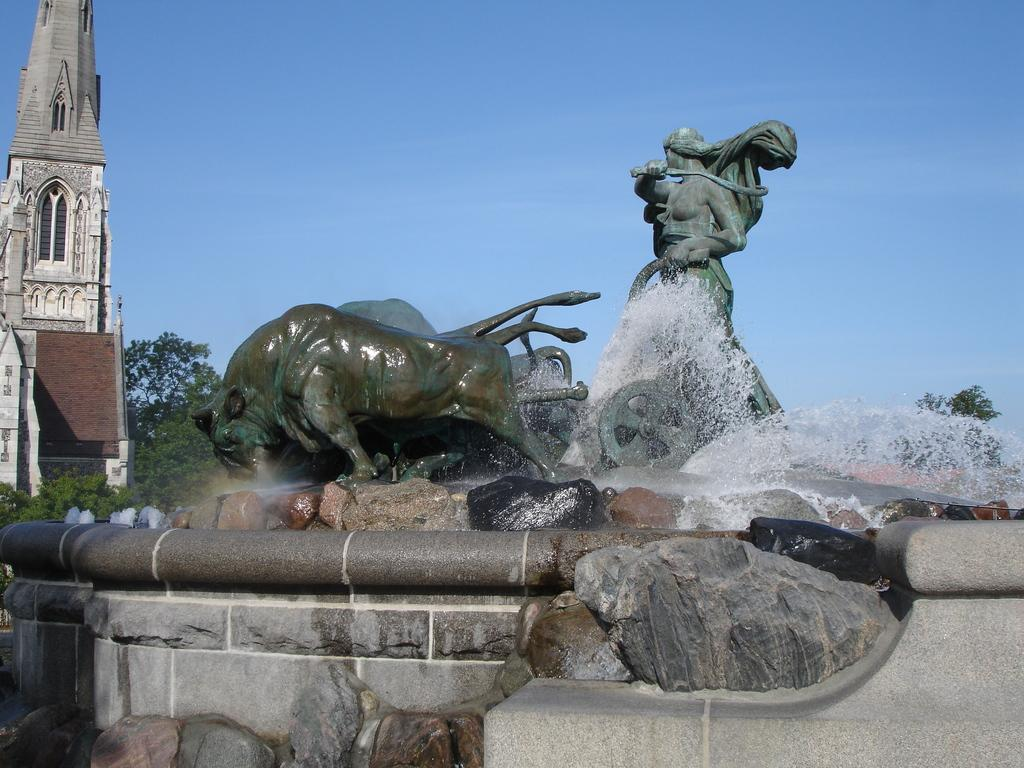What can be seen in the sky in the image? The sky with clouds is visible in the image. What type of natural vegetation is present in the image? There are trees in the image. What type of man-made structures are present in the image? There are buildings in the image. What type of artistic objects are present in the image? There are sculptures in the image. What type of water feature is present in the image? There is a fountain in the image. Can you see any bees buzzing around the sculptures in the image? There are no bees visible in the image. What type of toy is present in the image? There are no toys present in the image. 